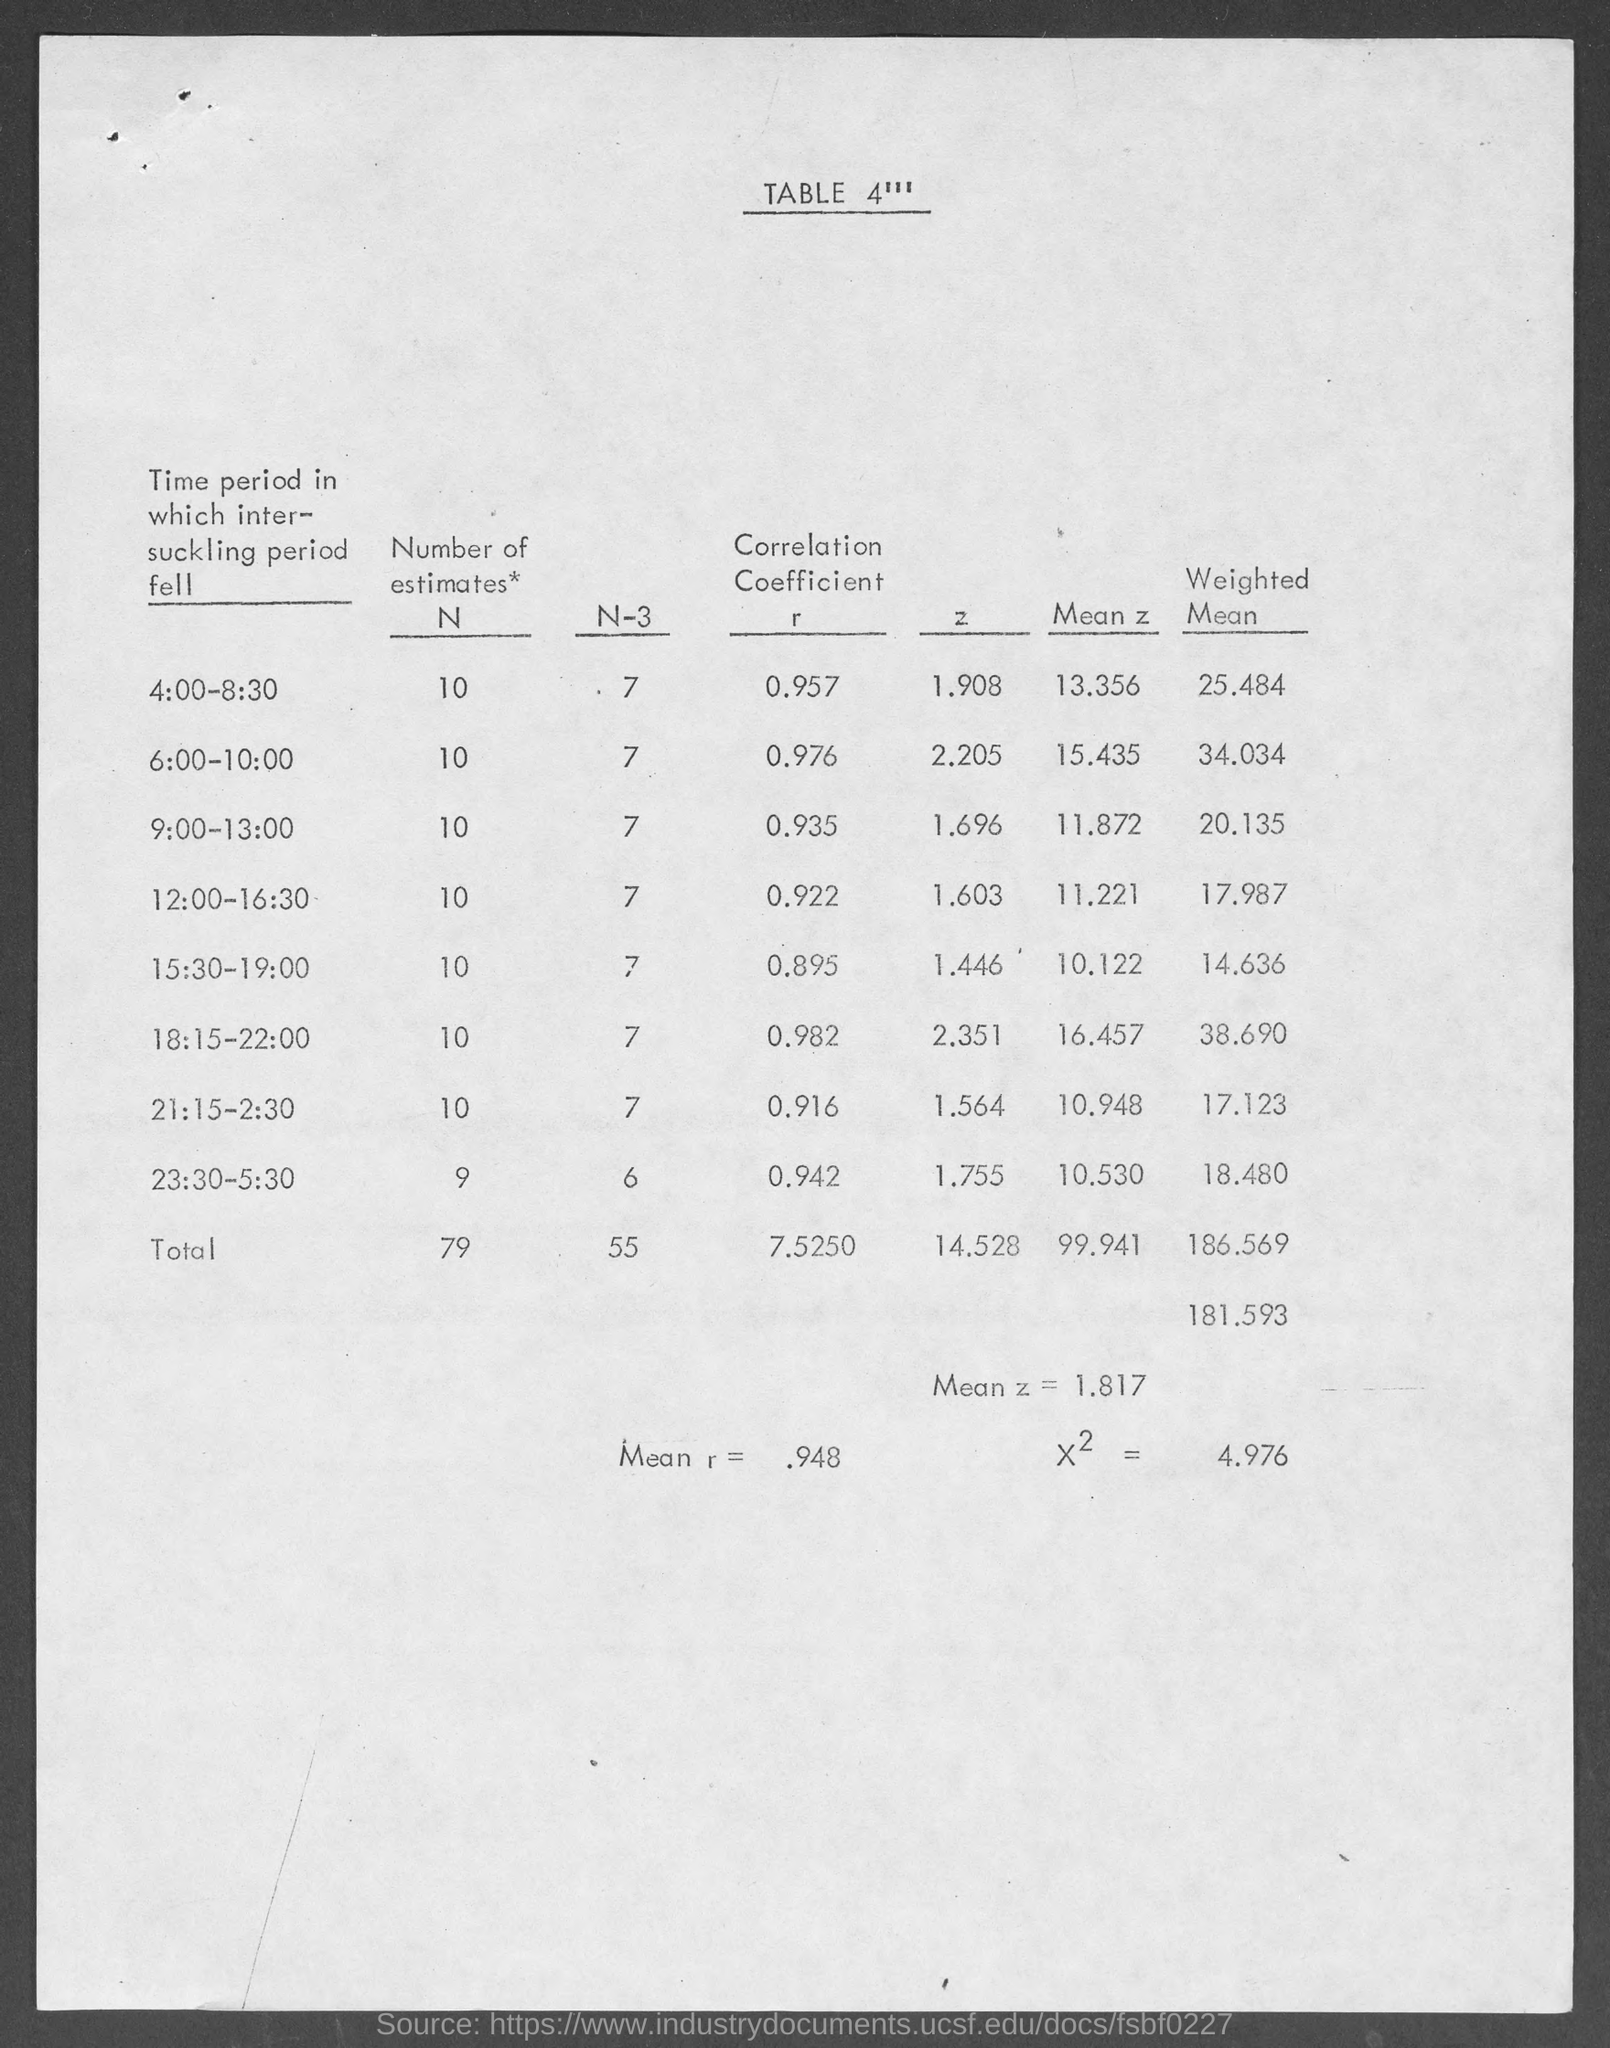List a handful of essential elements in this visual. The last column heading of the table is 'Weighted Mean.' The total mean of r is approximately 0.948. What is the table number? TABLE 4 is the correct answer. The total mean of z is 1.817... 